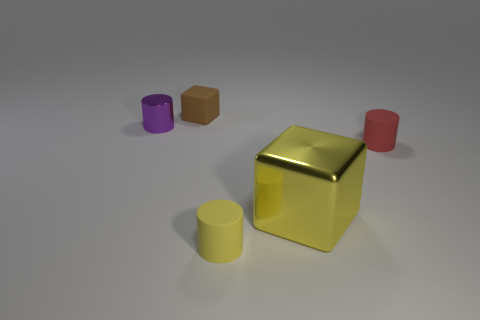Are there any other things that are the same size as the metallic cube?
Your answer should be compact. No. What number of rubber blocks are the same color as the big shiny block?
Give a very brief answer. 0. The yellow matte cylinder has what size?
Make the answer very short. Small. Is the red matte thing the same size as the purple cylinder?
Offer a terse response. Yes. The matte object that is on the left side of the yellow shiny object and in front of the metallic cylinder is what color?
Give a very brief answer. Yellow. What number of brown objects are the same material as the tiny yellow object?
Make the answer very short. 1. What number of large yellow metal spheres are there?
Offer a very short reply. 0. Is the size of the purple cylinder the same as the cube right of the rubber cube?
Make the answer very short. No. There is a thing right of the yellow object to the right of the small yellow cylinder; what is it made of?
Your response must be concise. Rubber. There is a yellow metallic block behind the tiny cylinder in front of the block to the right of the brown matte cube; what is its size?
Make the answer very short. Large. 